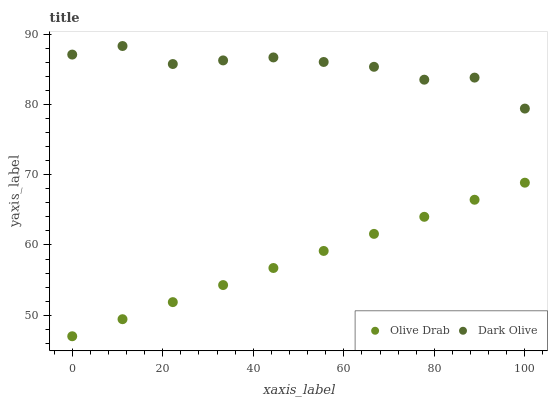Does Olive Drab have the minimum area under the curve?
Answer yes or no. Yes. Does Dark Olive have the maximum area under the curve?
Answer yes or no. Yes. Does Olive Drab have the maximum area under the curve?
Answer yes or no. No. Is Olive Drab the smoothest?
Answer yes or no. Yes. Is Dark Olive the roughest?
Answer yes or no. Yes. Is Olive Drab the roughest?
Answer yes or no. No. Does Olive Drab have the lowest value?
Answer yes or no. Yes. Does Dark Olive have the highest value?
Answer yes or no. Yes. Does Olive Drab have the highest value?
Answer yes or no. No. Is Olive Drab less than Dark Olive?
Answer yes or no. Yes. Is Dark Olive greater than Olive Drab?
Answer yes or no. Yes. Does Olive Drab intersect Dark Olive?
Answer yes or no. No. 